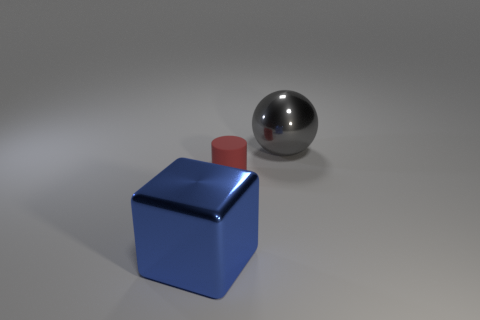Add 1 gray metal cylinders. How many objects exist? 4 Subtract all spheres. How many objects are left? 2 Add 3 matte cylinders. How many matte cylinders exist? 4 Subtract 0 red balls. How many objects are left? 3 Subtract all blue metallic objects. Subtract all big blue metal things. How many objects are left? 1 Add 1 tiny cylinders. How many tiny cylinders are left? 2 